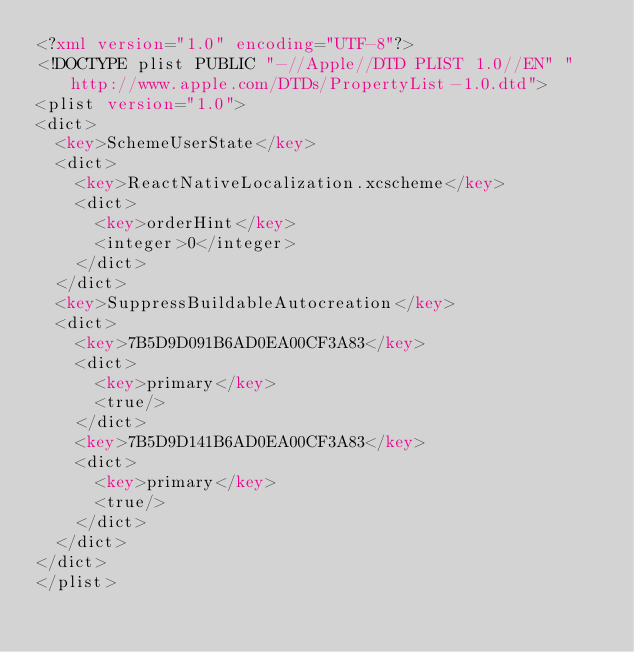Convert code to text. <code><loc_0><loc_0><loc_500><loc_500><_XML_><?xml version="1.0" encoding="UTF-8"?>
<!DOCTYPE plist PUBLIC "-//Apple//DTD PLIST 1.0//EN" "http://www.apple.com/DTDs/PropertyList-1.0.dtd">
<plist version="1.0">
<dict>
	<key>SchemeUserState</key>
	<dict>
		<key>ReactNativeLocalization.xcscheme</key>
		<dict>
			<key>orderHint</key>
			<integer>0</integer>
		</dict>
	</dict>
	<key>SuppressBuildableAutocreation</key>
	<dict>
		<key>7B5D9D091B6AD0EA00CF3A83</key>
		<dict>
			<key>primary</key>
			<true/>
		</dict>
		<key>7B5D9D141B6AD0EA00CF3A83</key>
		<dict>
			<key>primary</key>
			<true/>
		</dict>
	</dict>
</dict>
</plist>
</code> 